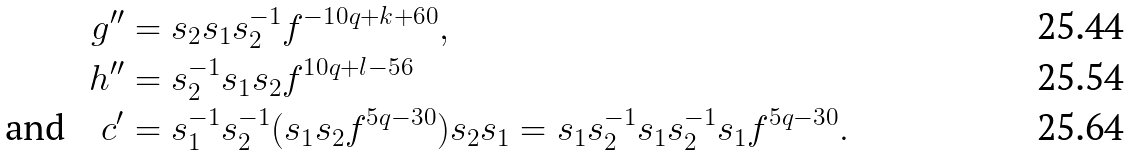<formula> <loc_0><loc_0><loc_500><loc_500>g ^ { \prime \prime } & = s _ { 2 } s _ { 1 } s _ { 2 } ^ { - 1 } f ^ { - 1 0 q + k + 6 0 } , \\ h ^ { \prime \prime } & = s _ { 2 } ^ { - 1 } s _ { 1 } s _ { 2 } f ^ { 1 0 q + l - 5 6 } \\ \text {and} \quad c ^ { \prime } & = s _ { 1 } ^ { - 1 } s _ { 2 } ^ { - 1 } ( s _ { 1 } s _ { 2 } f ^ { 5 q - 3 0 } ) s _ { 2 } s _ { 1 } = s _ { 1 } s _ { 2 } ^ { - 1 } s _ { 1 } s _ { 2 } ^ { - 1 } s _ { 1 } f ^ { 5 q - 3 0 } .</formula> 